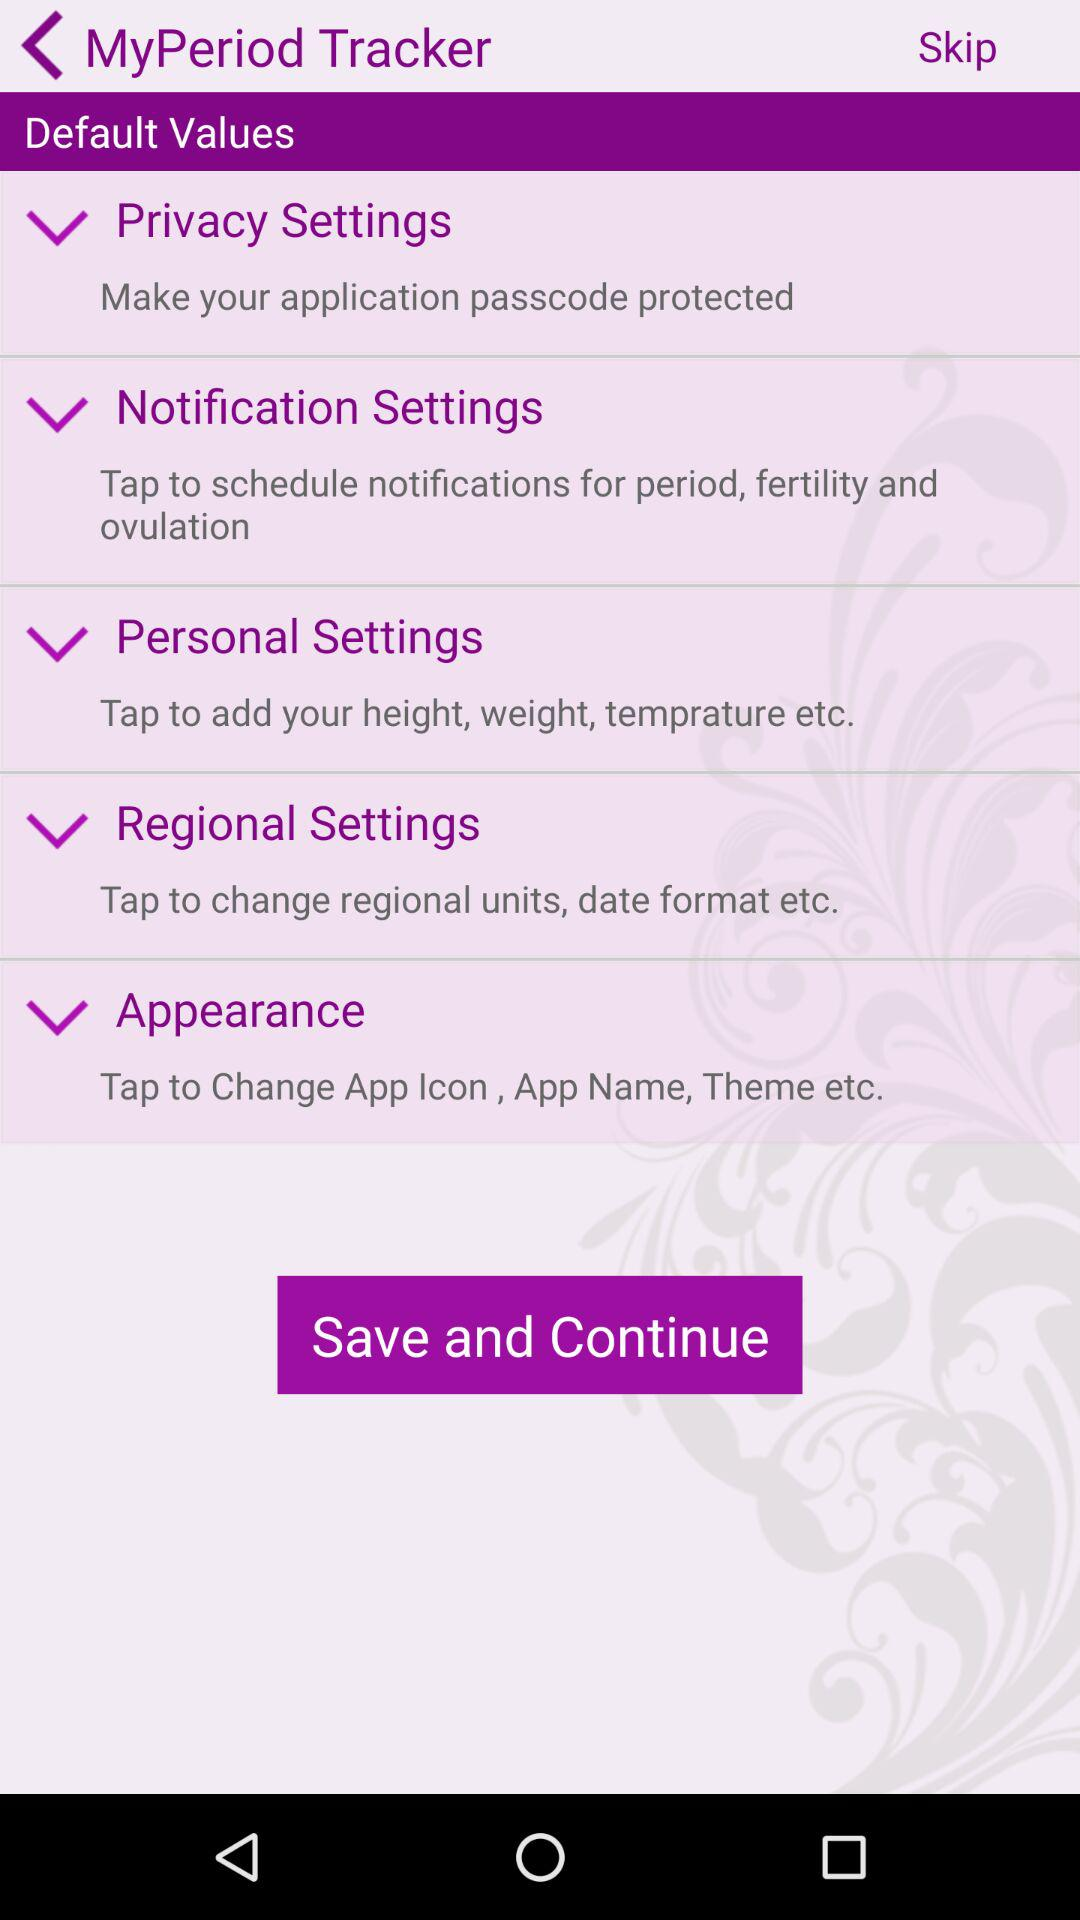What is the application name?
When the provided information is insufficient, respond with <no answer>. <no answer> 